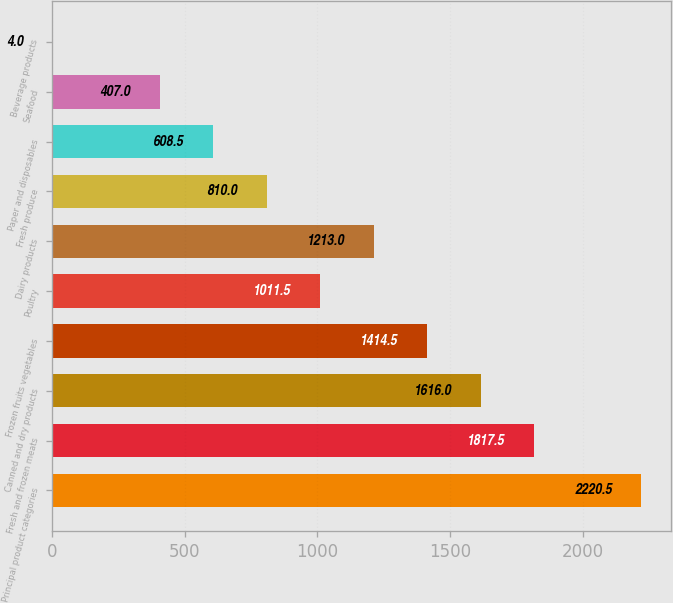<chart> <loc_0><loc_0><loc_500><loc_500><bar_chart><fcel>Principal product categories<fcel>Fresh and frozen meats<fcel>Canned and dry products<fcel>Frozen fruits vegetables<fcel>Poultry<fcel>Dairy products<fcel>Fresh produce<fcel>Paper and disposables<fcel>Seafood<fcel>Beverage products<nl><fcel>2220.5<fcel>1817.5<fcel>1616<fcel>1414.5<fcel>1011.5<fcel>1213<fcel>810<fcel>608.5<fcel>407<fcel>4<nl></chart> 